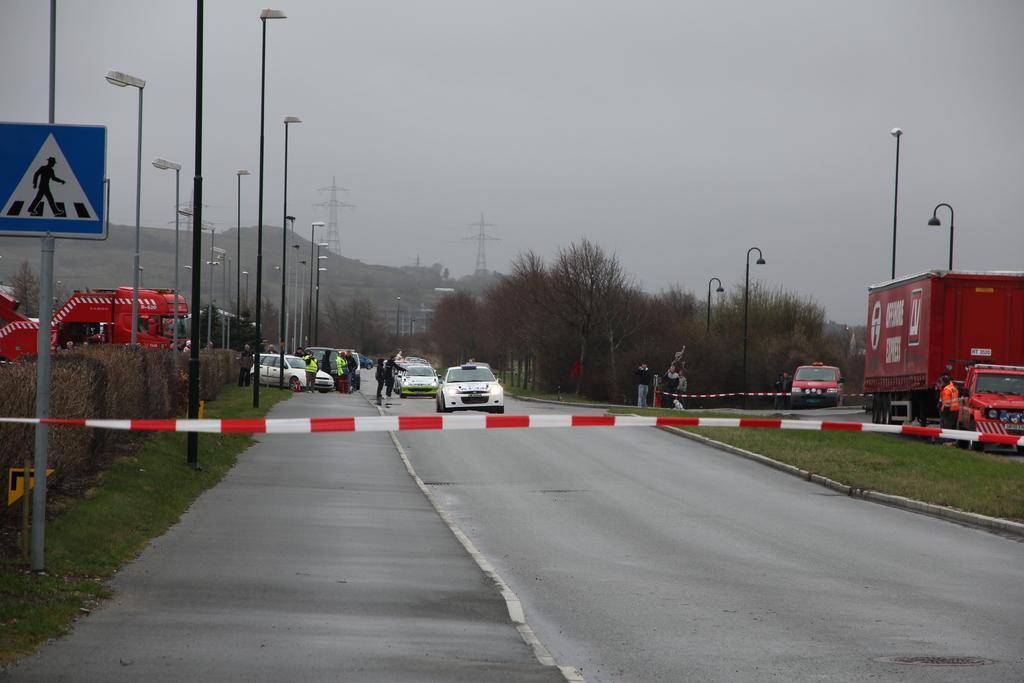Please provide a concise description of this image. In this image, we can see caution tapes, vehicles, plants, trees, poles, few people, sign boards, grass and roads. Background we can see hills, transmission towers and sky. 